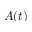Convert formula to latex. <formula><loc_0><loc_0><loc_500><loc_500>A ( t )</formula> 